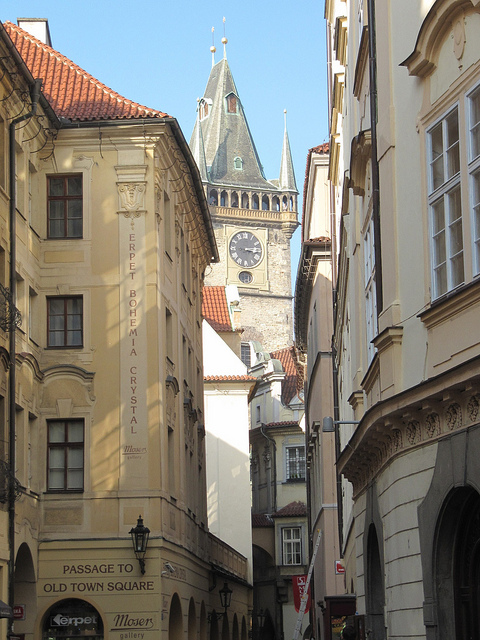Identify the text contained in this image. ERPET BOHEMIA CRYSTAL PASSAGE OLD Mosers SQUARE TOWN TO 